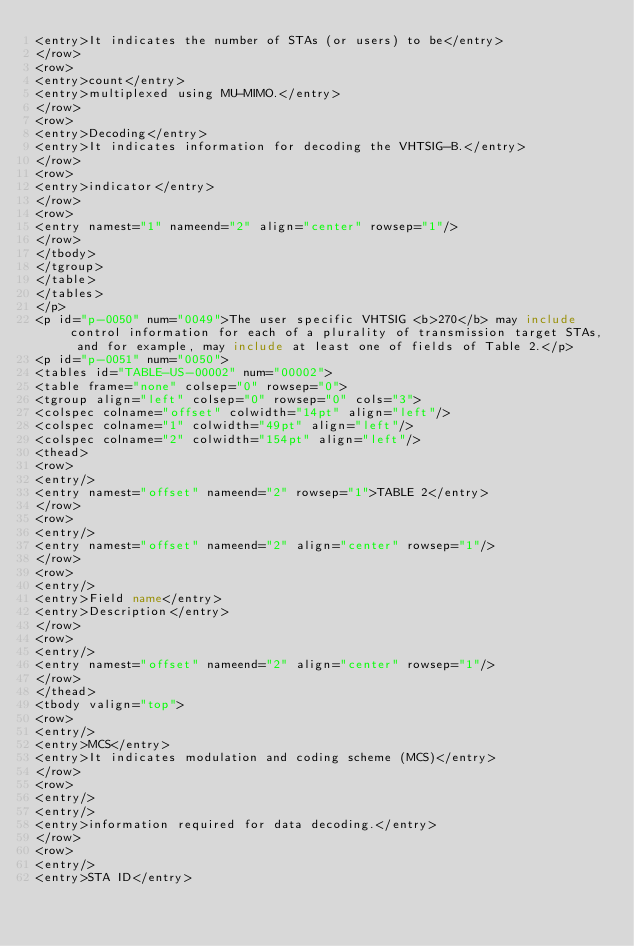<code> <loc_0><loc_0><loc_500><loc_500><_XML_><entry>It indicates the number of STAs (or users) to be</entry>
</row>
<row>
<entry>count</entry>
<entry>multiplexed using MU-MIMO.</entry>
</row>
<row>
<entry>Decoding</entry>
<entry>It indicates information for decoding the VHTSIG-B.</entry>
</row>
<row>
<entry>indicator</entry>
</row>
<row>
<entry namest="1" nameend="2" align="center" rowsep="1"/>
</row>
</tbody>
</tgroup>
</table>
</tables>
</p>
<p id="p-0050" num="0049">The user specific VHTSIG <b>270</b> may include control information for each of a plurality of transmission target STAs, and for example, may include at least one of fields of Table 2.</p>
<p id="p-0051" num="0050">
<tables id="TABLE-US-00002" num="00002">
<table frame="none" colsep="0" rowsep="0">
<tgroup align="left" colsep="0" rowsep="0" cols="3">
<colspec colname="offset" colwidth="14pt" align="left"/>
<colspec colname="1" colwidth="49pt" align="left"/>
<colspec colname="2" colwidth="154pt" align="left"/>
<thead>
<row>
<entry/>
<entry namest="offset" nameend="2" rowsep="1">TABLE 2</entry>
</row>
<row>
<entry/>
<entry namest="offset" nameend="2" align="center" rowsep="1"/>
</row>
<row>
<entry/>
<entry>Field name</entry>
<entry>Description</entry>
</row>
<row>
<entry/>
<entry namest="offset" nameend="2" align="center" rowsep="1"/>
</row>
</thead>
<tbody valign="top">
<row>
<entry/>
<entry>MCS</entry>
<entry>It indicates modulation and coding scheme (MCS)</entry>
</row>
<row>
<entry/>
<entry/>
<entry>information required for data decoding.</entry>
</row>
<row>
<entry/>
<entry>STA ID</entry></code> 